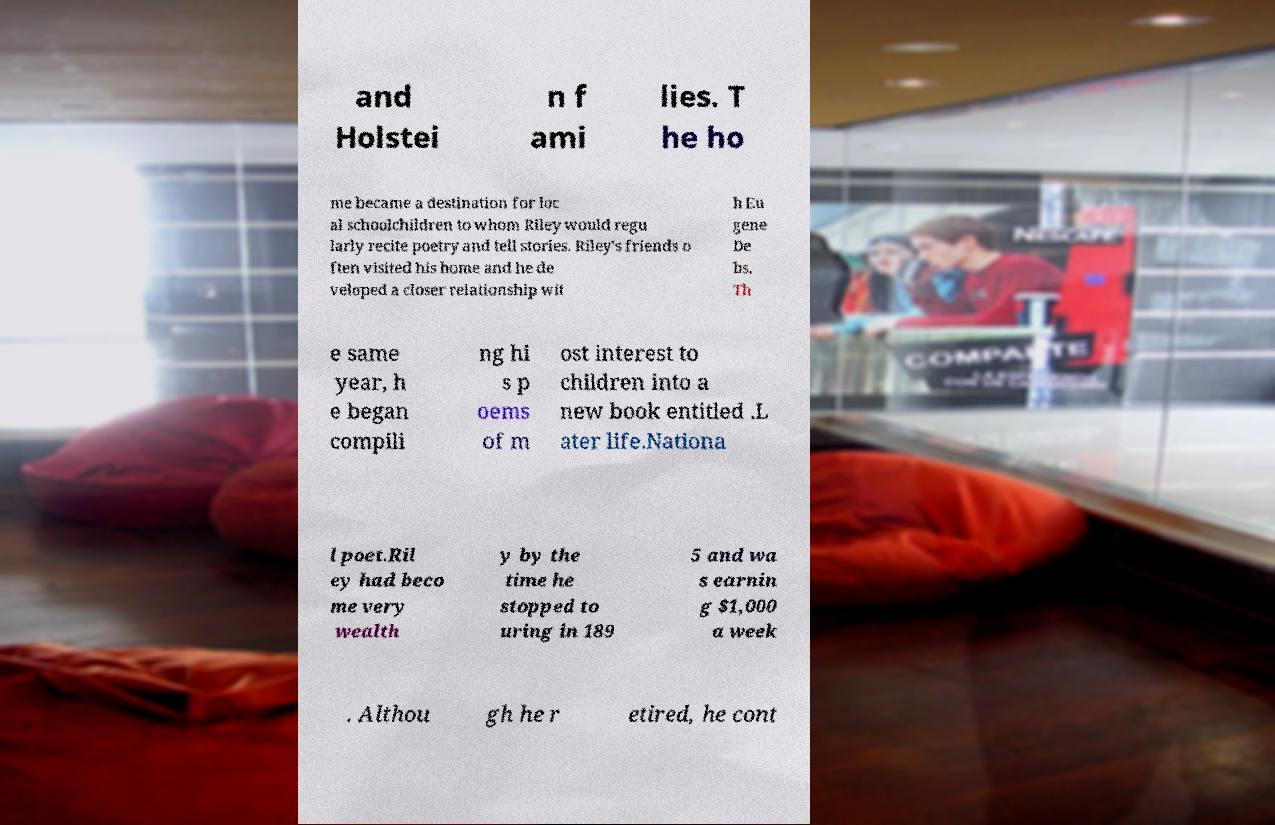Please identify and transcribe the text found in this image. and Holstei n f ami lies. T he ho me became a destination for loc al schoolchildren to whom Riley would regu larly recite poetry and tell stories. Riley's friends o ften visited his home and he de veloped a closer relationship wit h Eu gene De bs. Th e same year, h e began compili ng hi s p oems of m ost interest to children into a new book entitled .L ater life.Nationa l poet.Ril ey had beco me very wealth y by the time he stopped to uring in 189 5 and wa s earnin g $1,000 a week . Althou gh he r etired, he cont 